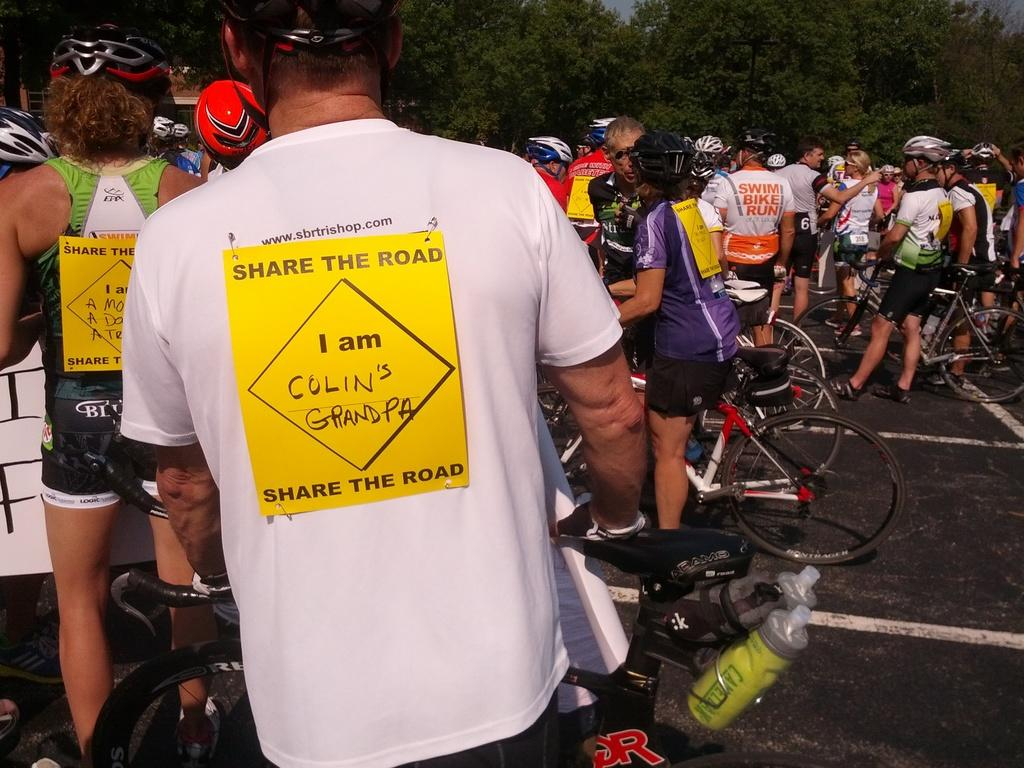Who or what can be seen in the image? There are persons in the image. What are the persons using in the image? There are bicycles in the image. What type of vegetation is visible at the top of the image? There are trees at the top of the image. What type of popcorn is being served to the father and duck in the image? There is no popcorn, father, or duck present in the image. 